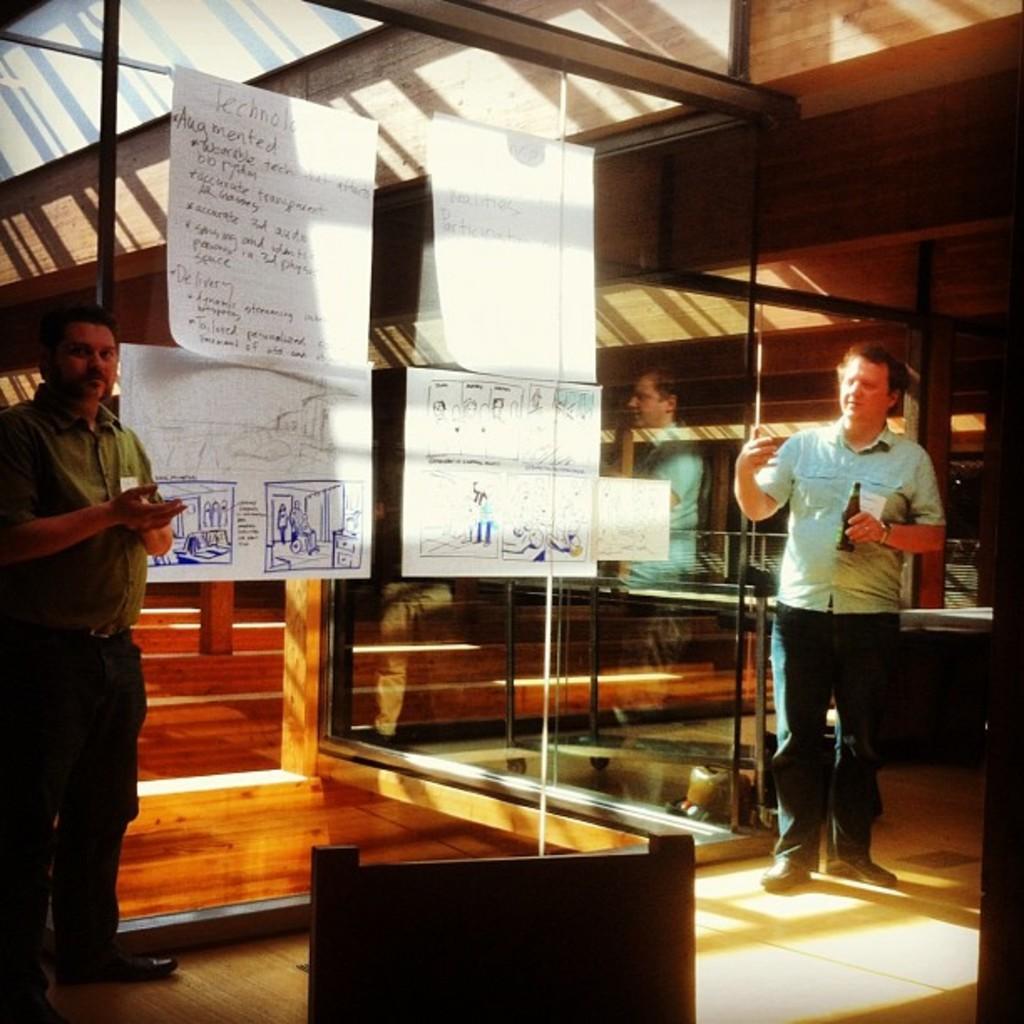Please provide a concise description of this image. In this image, we can see persons standing and wearing clothes. There are charts on the glass wall. There is an object at the bottom of the image. 